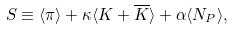Convert formula to latex. <formula><loc_0><loc_0><loc_500><loc_500>S \equiv \langle \pi \rangle + \kappa \langle K + \overline { K } \rangle + \alpha \langle N _ { P } \rangle ,</formula> 